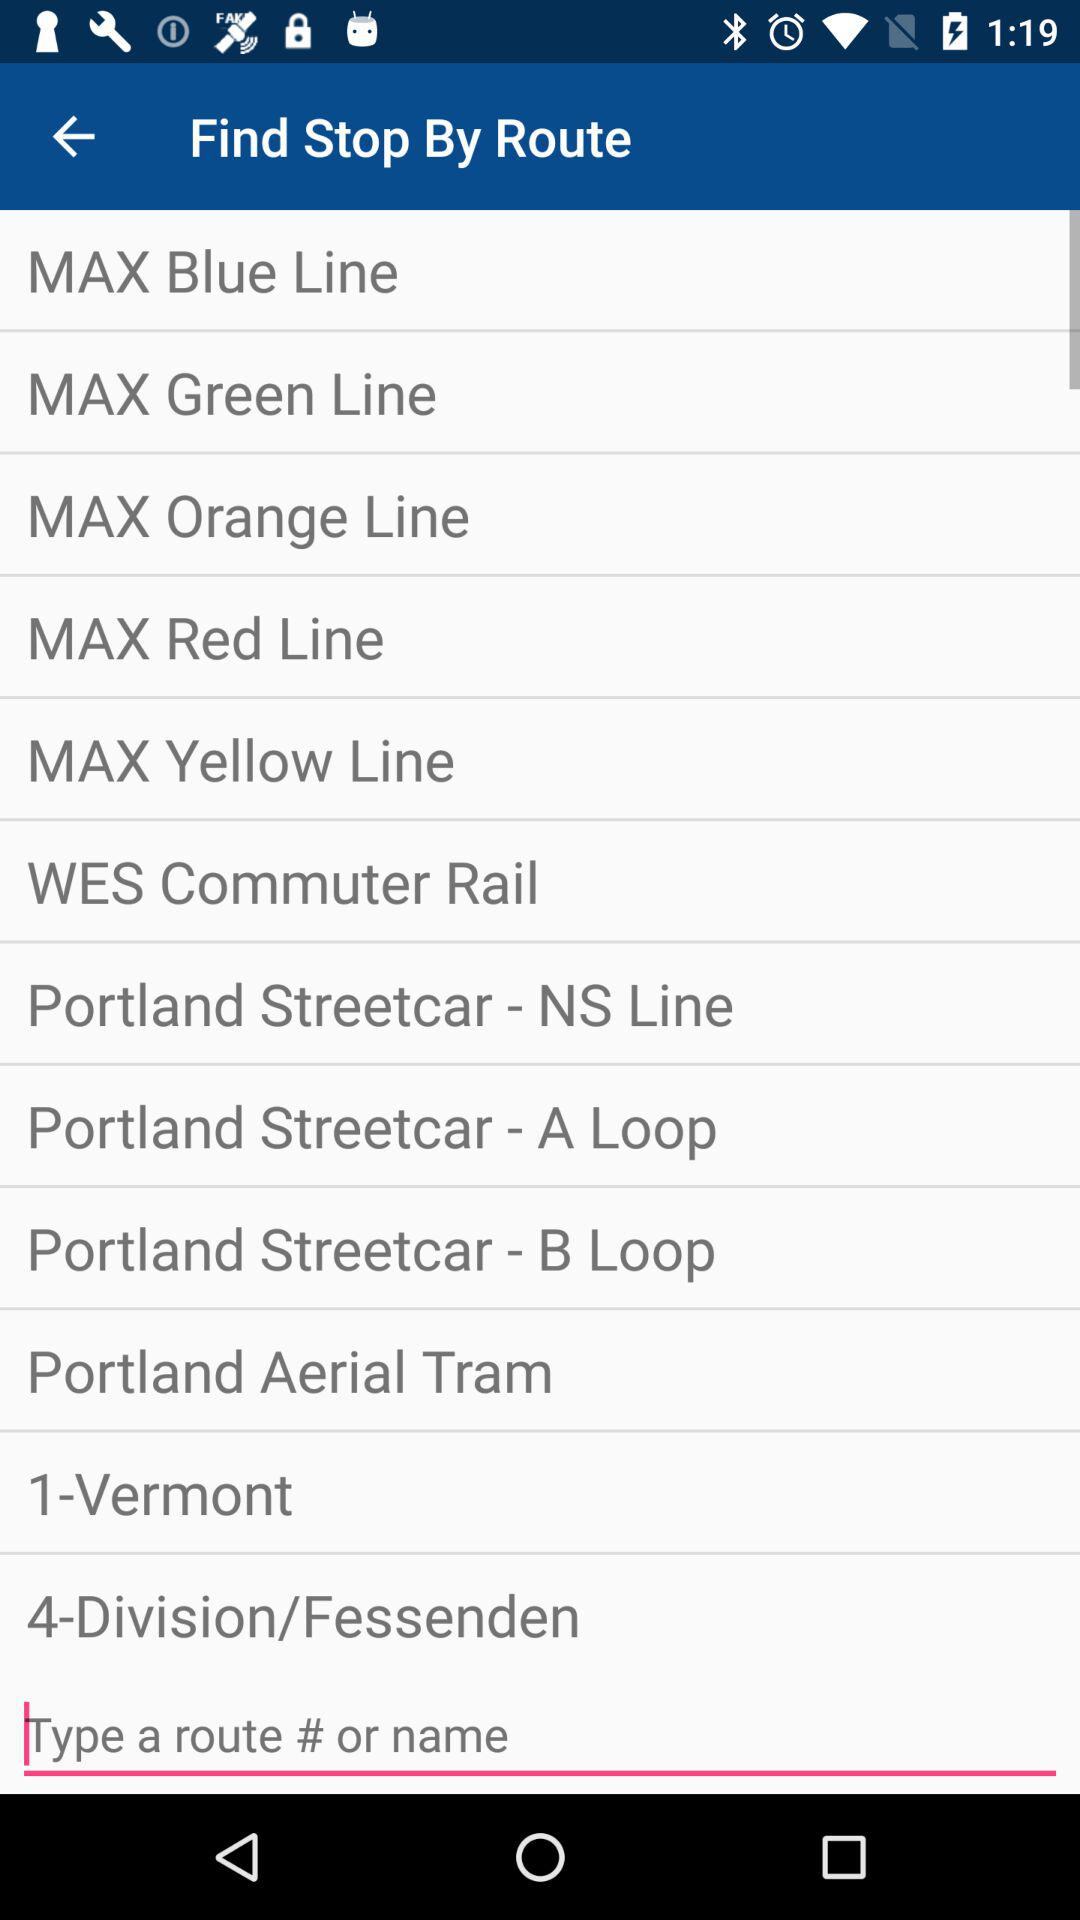How many Portland Streetcar lines are there?
Answer the question using a single word or phrase. 3 